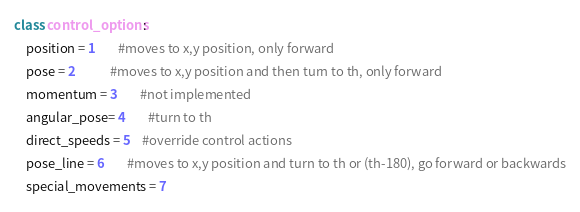<code> <loc_0><loc_0><loc_500><loc_500><_Python_>class control_options:
    position = 1		#moves to x,y position, only forward
    pose = 2			#moves to x,y position and then turn to th, only forward
    momentum = 3		#not implemented
    angular_pose= 4		#turn to th
    direct_speeds = 5	#override control actions
    pose_line = 6		#moves to x,y position and turn to th or (th-180), go forward or backwards
    special_movements = 7</code> 